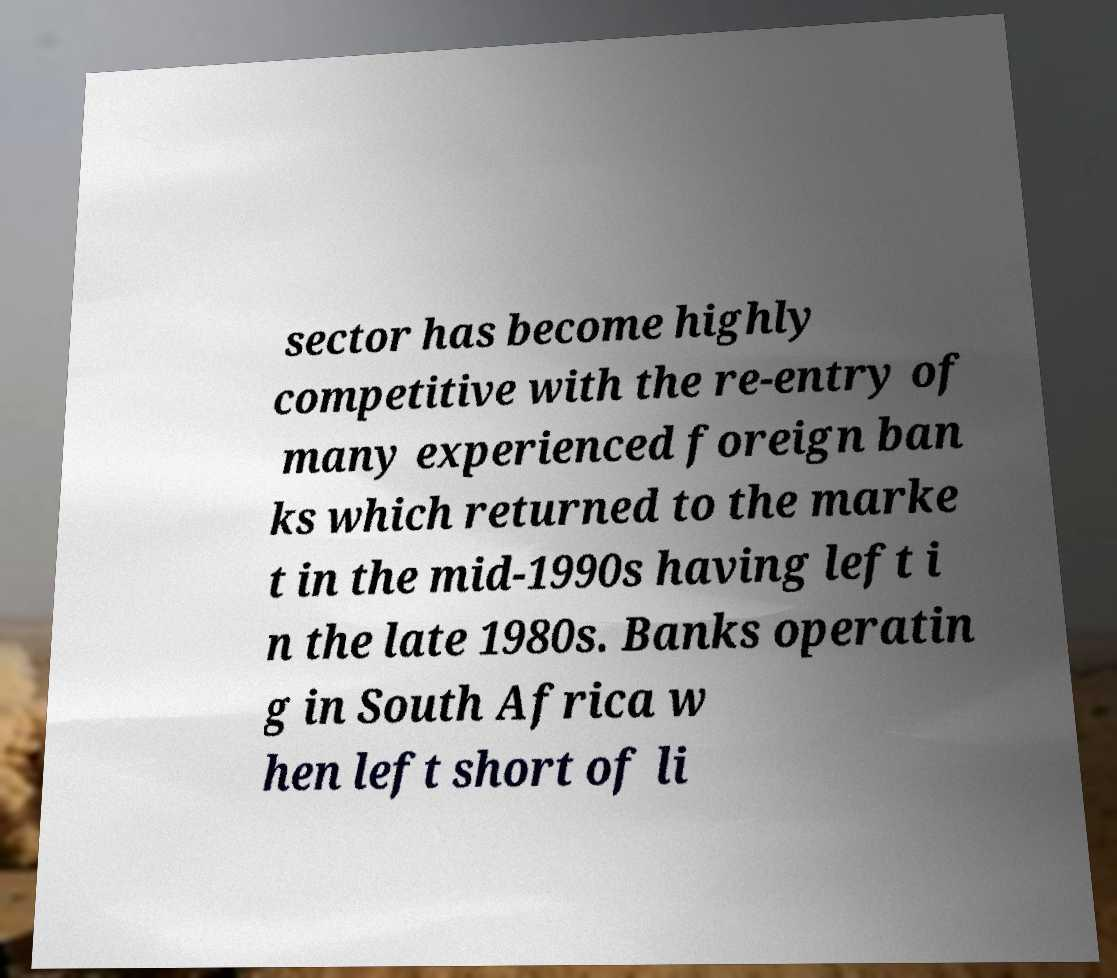Please read and relay the text visible in this image. What does it say? sector has become highly competitive with the re-entry of many experienced foreign ban ks which returned to the marke t in the mid-1990s having left i n the late 1980s. Banks operatin g in South Africa w hen left short of li 